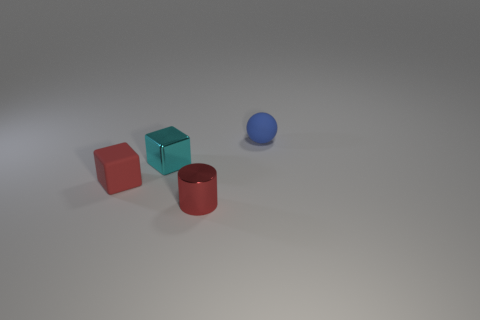Add 2 metal objects. How many objects exist? 6 Subtract all cylinders. How many objects are left? 3 Subtract 0 gray spheres. How many objects are left? 4 Subtract all tiny blue matte spheres. Subtract all tiny cyan things. How many objects are left? 2 Add 1 tiny blue rubber balls. How many tiny blue rubber balls are left? 2 Add 1 big matte things. How many big matte things exist? 1 